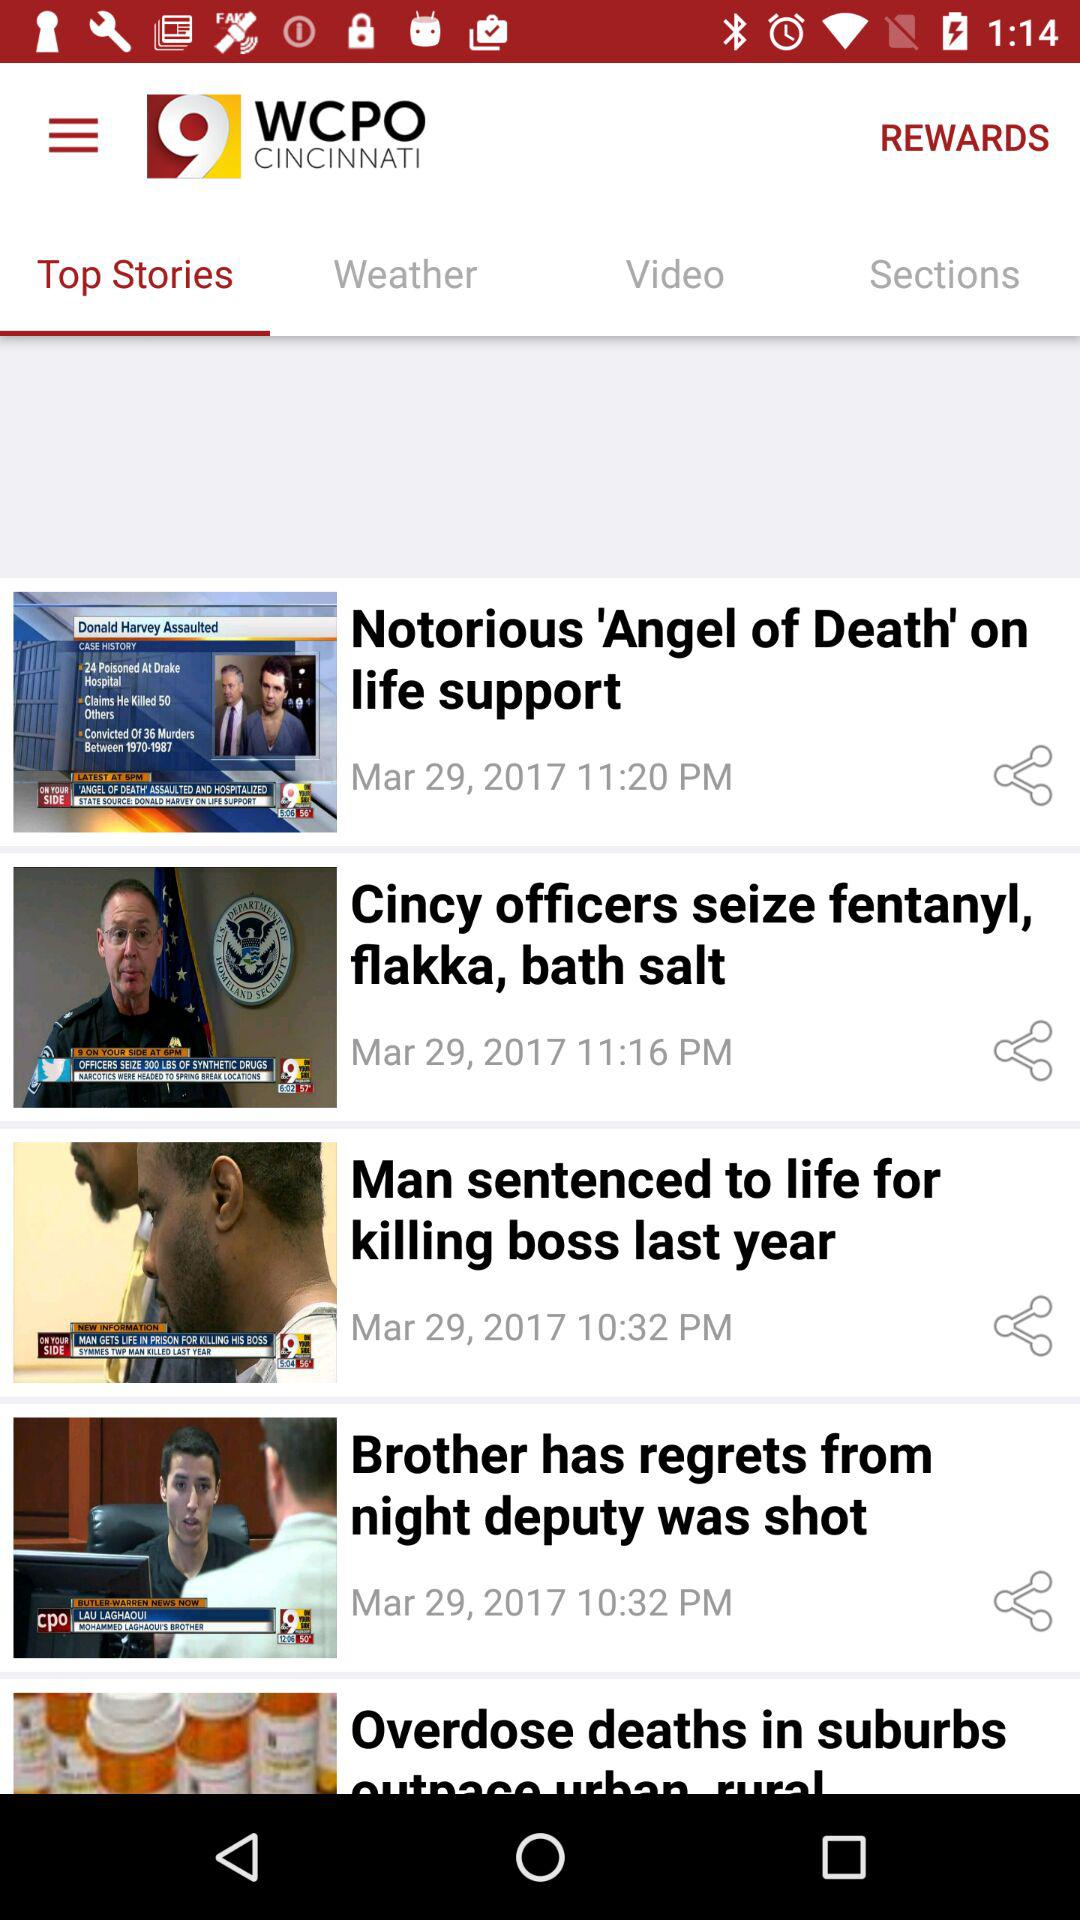Which tab is selected? The selected tab is "Top Stories". 